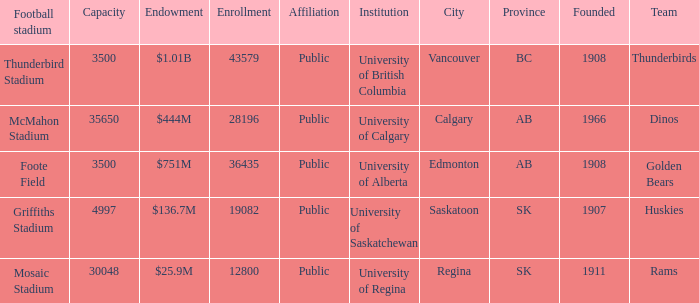What year was mcmahon stadium founded? 1966.0. 